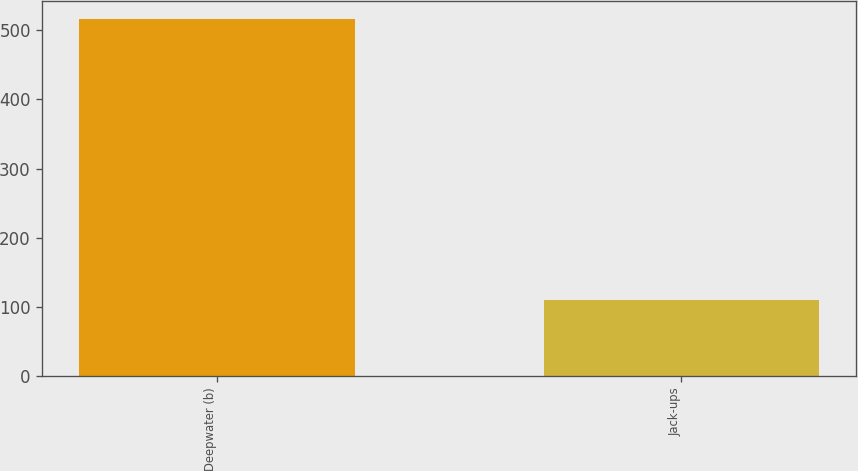<chart> <loc_0><loc_0><loc_500><loc_500><bar_chart><fcel>Deepwater (b)<fcel>Jack-ups<nl><fcel>516<fcel>110<nl></chart> 